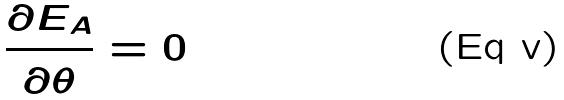Convert formula to latex. <formula><loc_0><loc_0><loc_500><loc_500>\frac { \partial E _ { A } } { \partial \theta } = 0</formula> 